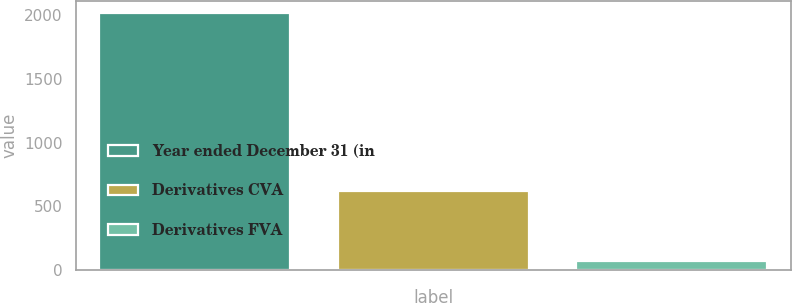<chart> <loc_0><loc_0><loc_500><loc_500><bar_chart><fcel>Year ended December 31 (in<fcel>Derivatives CVA<fcel>Derivatives FVA<nl><fcel>2015<fcel>620<fcel>73<nl></chart> 